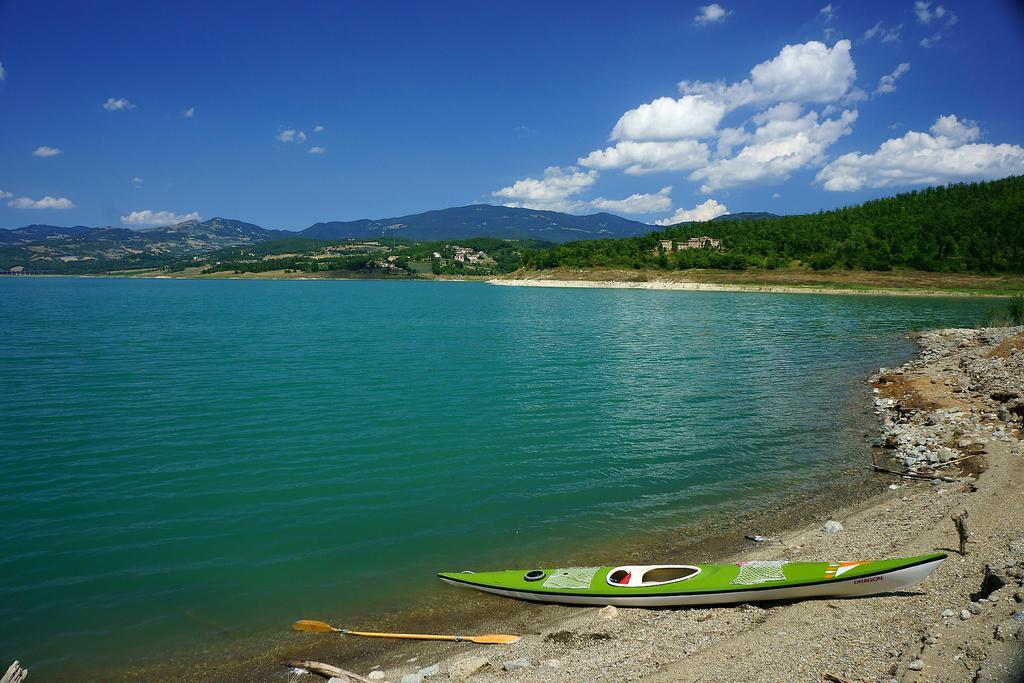In one or two sentences, can you explain what this image depicts? In this picture there is a sea surrounded with trees & mountains and there is a boat on the sea shore. Here the sky is blue. 